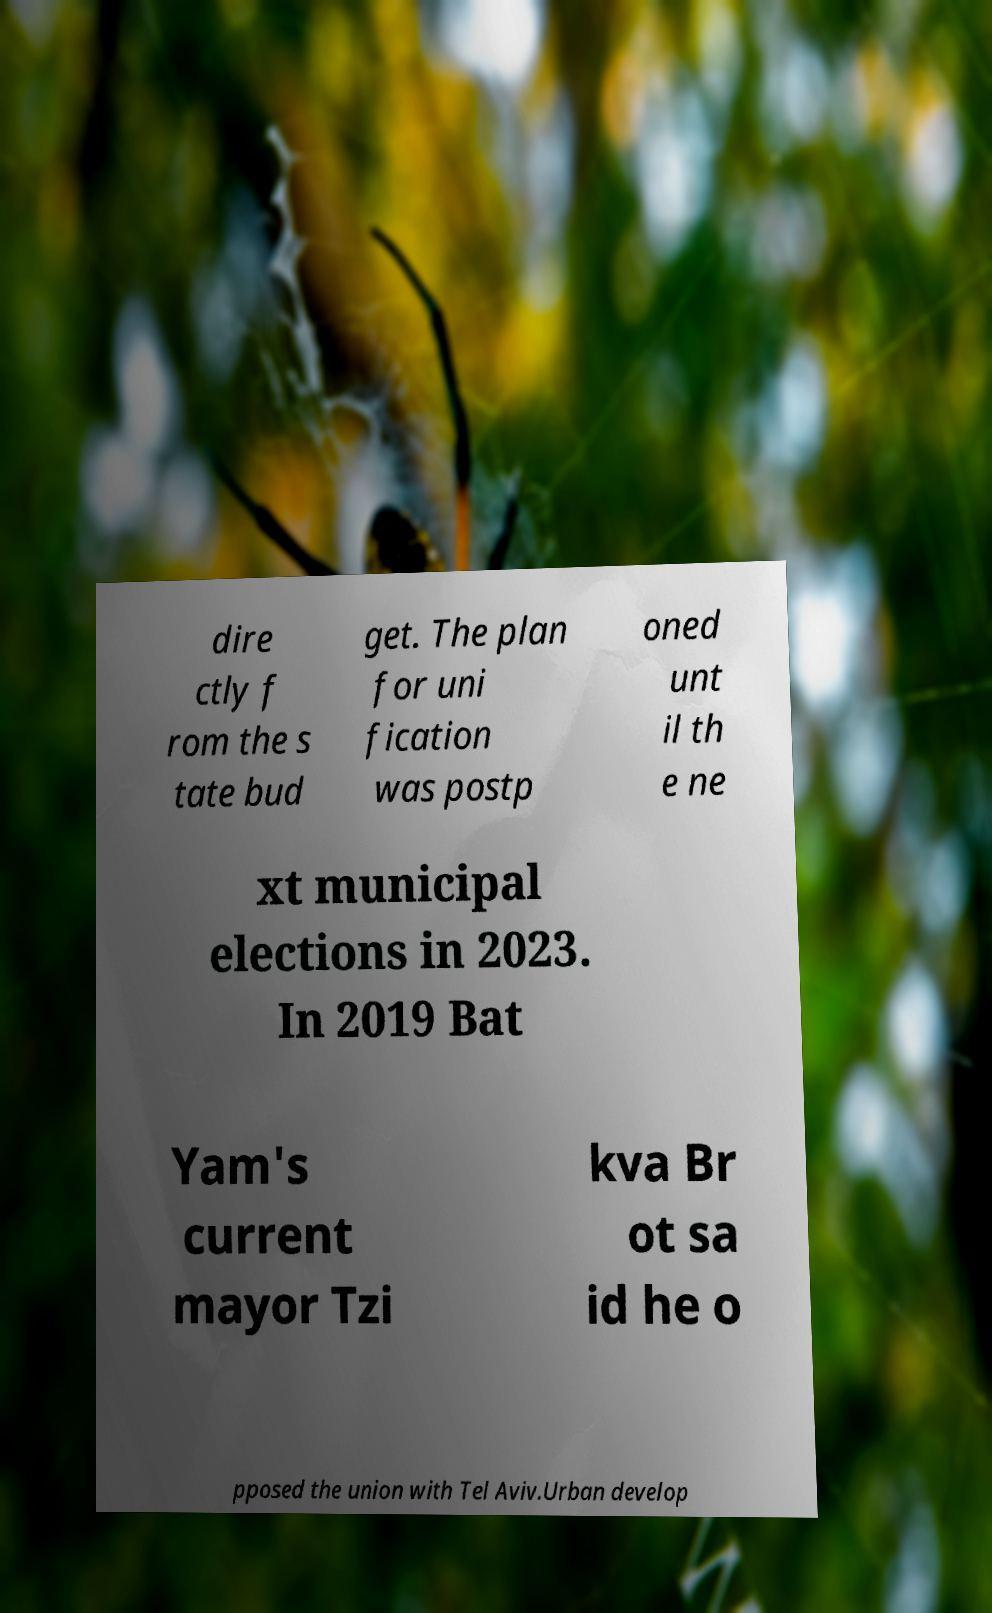Could you assist in decoding the text presented in this image and type it out clearly? dire ctly f rom the s tate bud get. The plan for uni fication was postp oned unt il th e ne xt municipal elections in 2023. In 2019 Bat Yam's current mayor Tzi kva Br ot sa id he o pposed the union with Tel Aviv.Urban develop 